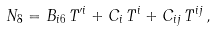<formula> <loc_0><loc_0><loc_500><loc_500>N _ { 8 } = B _ { i 6 } \, T ^ { \prime i } + C _ { i } \, T ^ { i } + C _ { i j } \, T ^ { i j } \, ,</formula> 